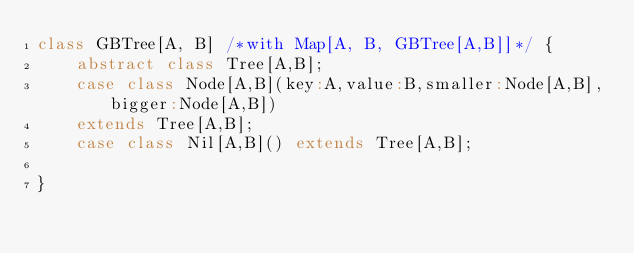Convert code to text. <code><loc_0><loc_0><loc_500><loc_500><_Scala_>class GBTree[A, B] /*with Map[A, B, GBTree[A,B]]*/ {
    abstract class Tree[A,B];
    case class Node[A,B](key:A,value:B,smaller:Node[A,B],bigger:Node[A,B])
	extends Tree[A,B];
    case class Nil[A,B]() extends Tree[A,B];

}
</code> 